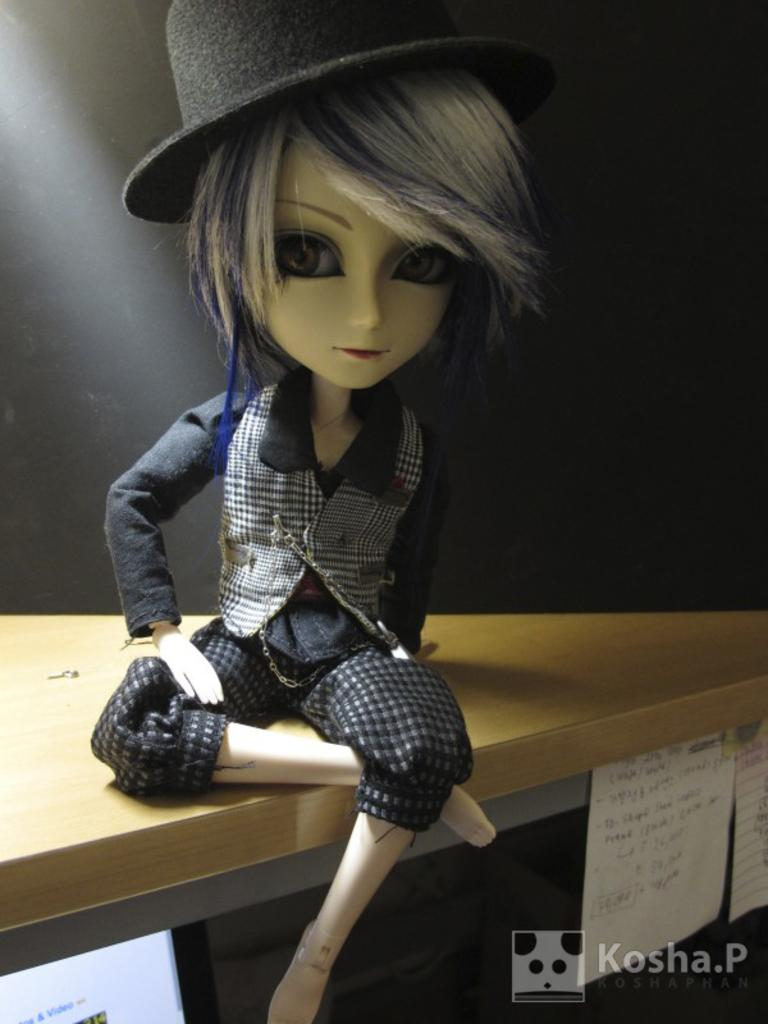What is the main subject of the image? There is a doll in the image. Where is the doll located? The doll is on a table. What is the doll wearing? The doll is wearing clothes and a hat. What type of feast is the doll attending in the image? There is no feast present in the image, and the doll is not attending any event. 